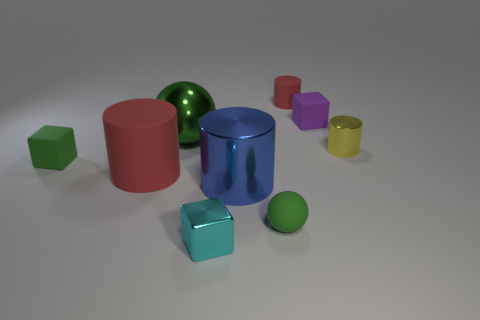Add 1 small yellow shiny cylinders. How many objects exist? 10 Subtract all balls. How many objects are left? 7 Subtract 0 brown spheres. How many objects are left? 9 Subtract all big red blocks. Subtract all big green things. How many objects are left? 8 Add 4 red matte cylinders. How many red matte cylinders are left? 6 Add 1 tiny purple rubber objects. How many tiny purple rubber objects exist? 2 